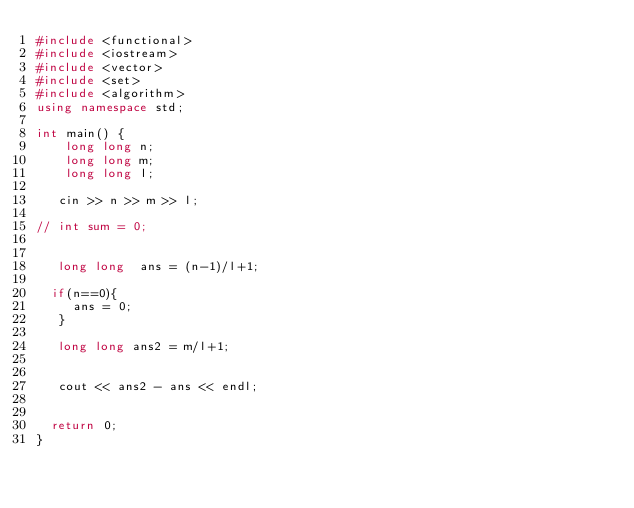<code> <loc_0><loc_0><loc_500><loc_500><_C++_>#include <functional>
#include <iostream>
#include <vector>
#include <set>
#include <algorithm>
using namespace std;

int main() {
    long long n;
    long long m;
    long long l;
 
   cin >> n >> m >> l;
  
// int sum = 0;
   
   
   long long  ans = (n-1)/l+1;
  
  if(n==0){
     ans = 0;
   }
  
   long long ans2 = m/l+1;
   
            
   cout << ans2 - ans << endl;
 
  
  return 0;
}</code> 